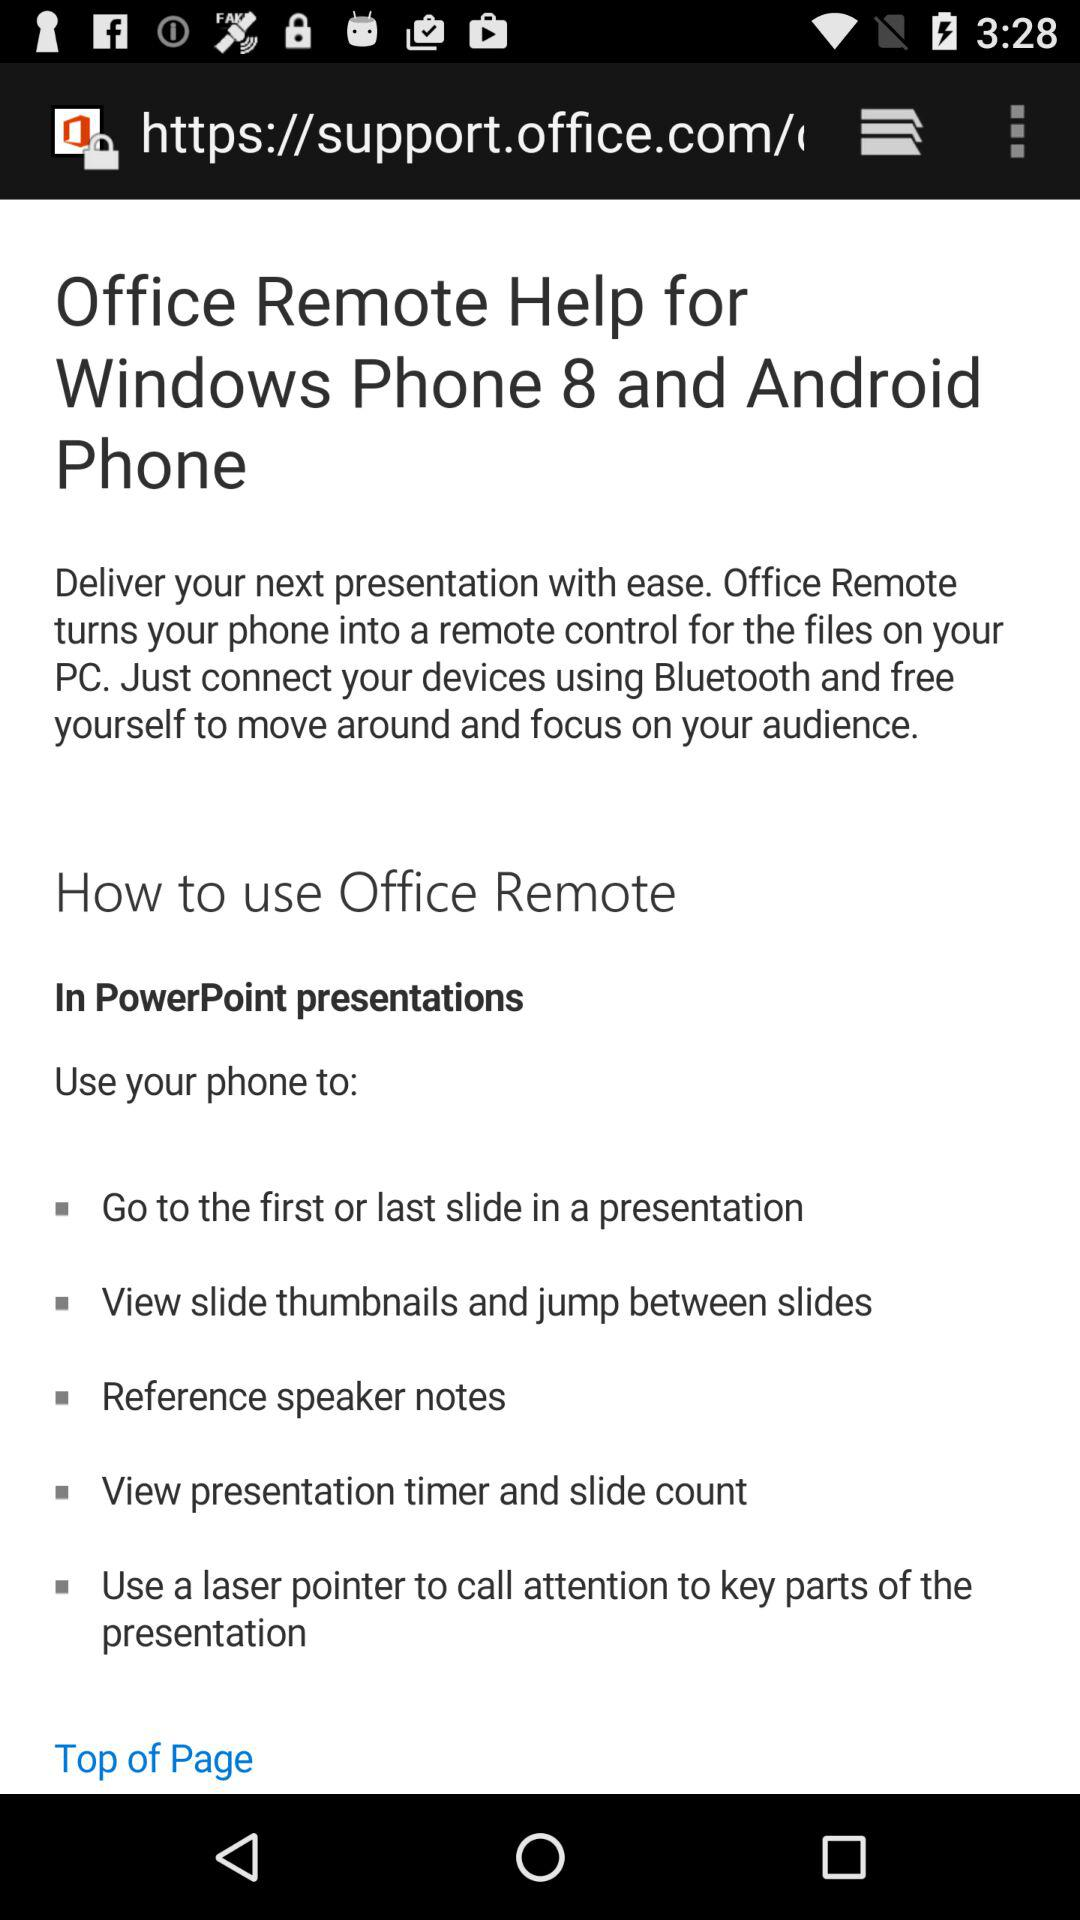What is the headline of the article? The headline is "Office Remote Help for Windows Phone 8 and Android Phone". 